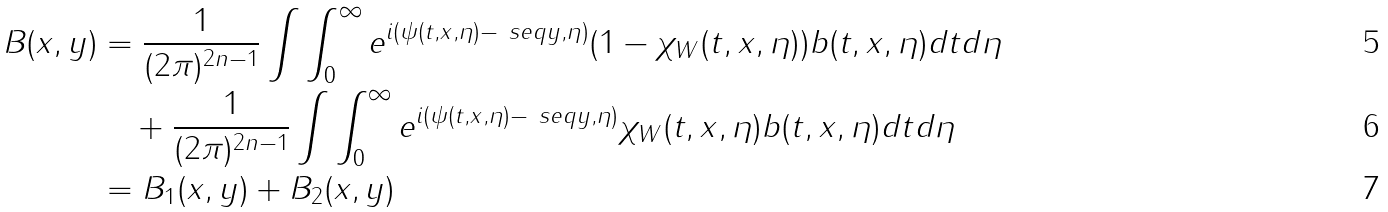<formula> <loc_0><loc_0><loc_500><loc_500>B ( x , y ) & = \frac { 1 } { ( 2 \pi ) ^ { 2 n - 1 } } \int \int ^ { \infty } _ { 0 } e ^ { i ( \psi ( t , x , \eta ) - \ s e q { y , \eta } ) } ( 1 - \chi _ { W } ( t , x , \eta ) ) b ( t , x , \eta ) d t d \eta \\ & \quad + \frac { 1 } { ( 2 \pi ) ^ { 2 n - 1 } } \int \int ^ { \infty } _ { 0 } e ^ { i ( \psi ( t , x , \eta ) - \ s e q { y , \eta } ) } \chi _ { W } ( t , x , \eta ) b ( t , x , \eta ) d t d \eta \\ & = B _ { 1 } ( x , y ) + B _ { 2 } ( x , y )</formula> 